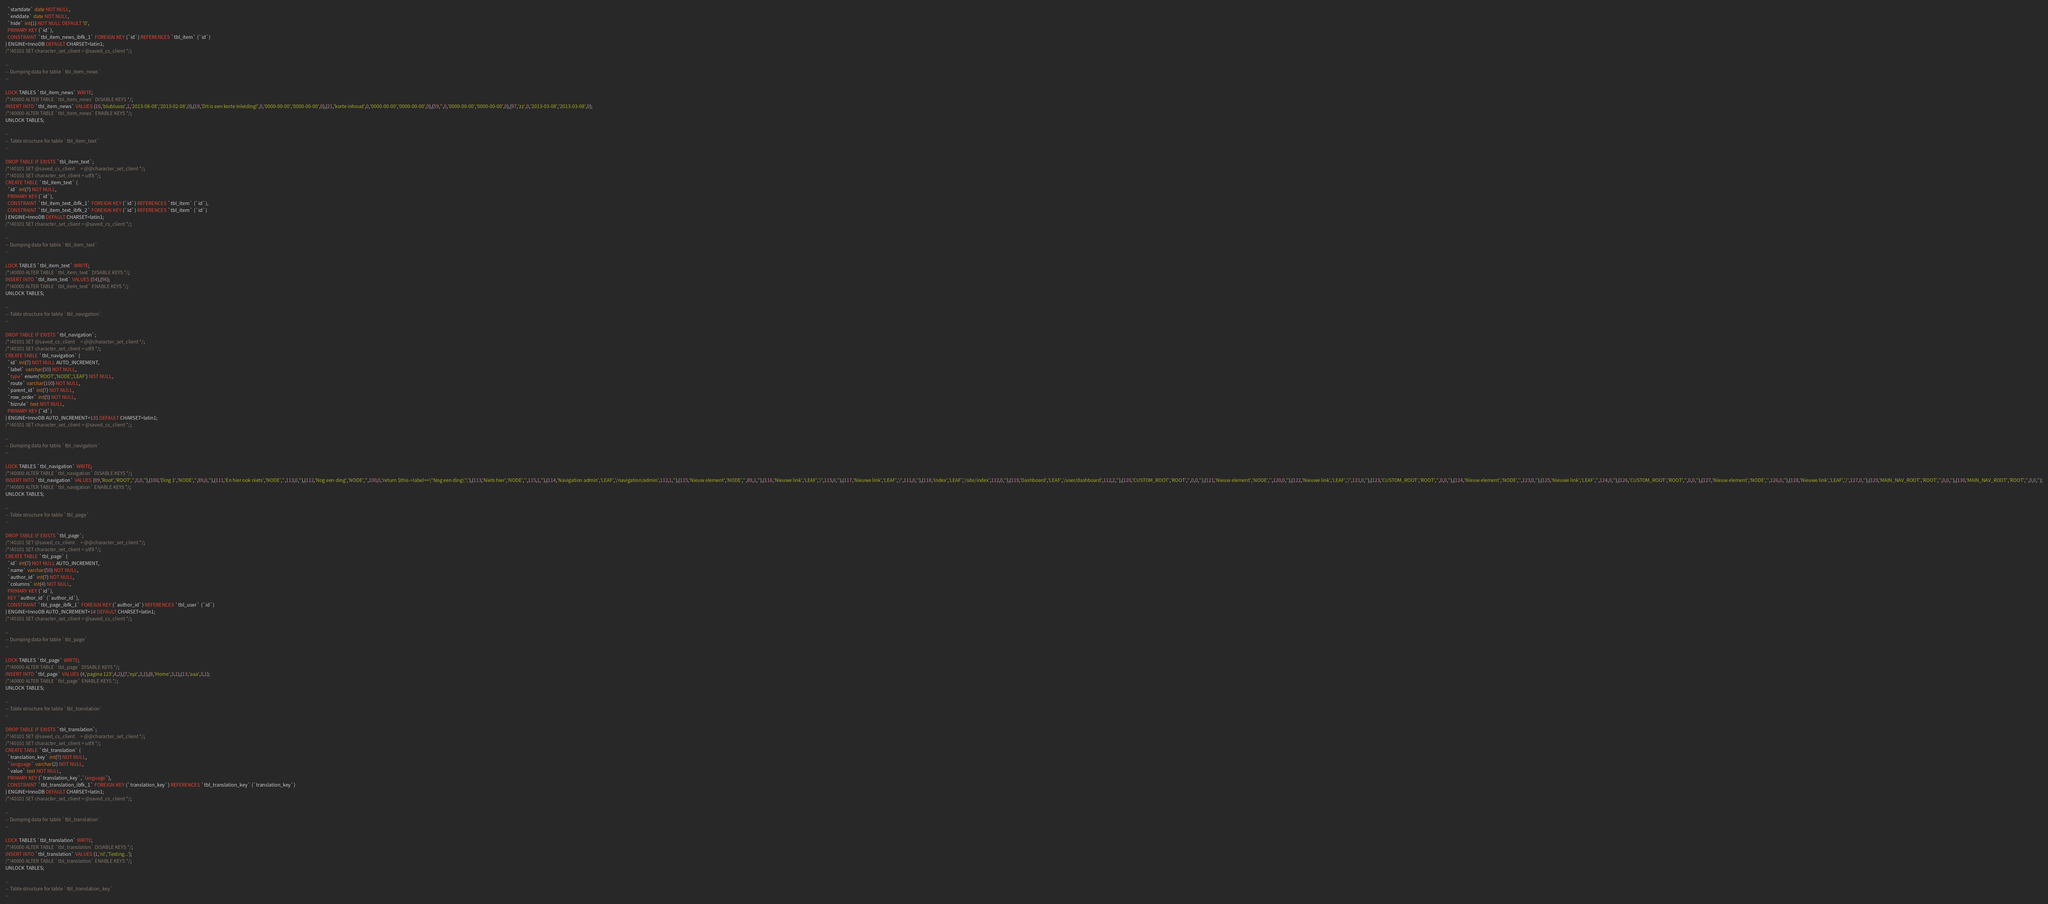Convert code to text. <code><loc_0><loc_0><loc_500><loc_500><_SQL_>  `startdate` date NOT NULL,
  `enddate` date NOT NULL,
  `hide` int(1) NOT NULL DEFAULT '0',
  PRIMARY KEY (`id`),
  CONSTRAINT `tbl_item_news_ibfk_1` FOREIGN KEY (`id`) REFERENCES `tbl_item` (`id`)
) ENGINE=InnoDB DEFAULT CHARSET=latin1;
/*!40101 SET character_set_client = @saved_cs_client */;

--
-- Dumping data for table `tbl_item_news`
--

LOCK TABLES `tbl_item_news` WRITE;
/*!40000 ALTER TABLE `tbl_item_news` DISABLE KEYS */;
INSERT INTO `tbl_item_news` VALUES (16,'blublusss',1,'2013-08-08','2013-02-08',0),(19,'Dit is een korte inleiding!',0,'0000-00-00','0000-00-00',0),(21,'korte inhoud',0,'0000-00-00','0000-00-00',0),(59,'',0,'0000-00-00','0000-00-00',0),(97,'zz',0,'2013-03-08','2013-03-08',0);
/*!40000 ALTER TABLE `tbl_item_news` ENABLE KEYS */;
UNLOCK TABLES;

--
-- Table structure for table `tbl_item_text`
--

DROP TABLE IF EXISTS `tbl_item_text`;
/*!40101 SET @saved_cs_client     = @@character_set_client */;
/*!40101 SET character_set_client = utf8 */;
CREATE TABLE `tbl_item_text` (
  `id` int(7) NOT NULL,
  PRIMARY KEY (`id`),
  CONSTRAINT `tbl_item_text_ibfk_1` FOREIGN KEY (`id`) REFERENCES `tbl_item` (`id`),
  CONSTRAINT `tbl_item_text_ibfk_2` FOREIGN KEY (`id`) REFERENCES `tbl_item` (`id`)
) ENGINE=InnoDB DEFAULT CHARSET=latin1;
/*!40101 SET character_set_client = @saved_cs_client */;

--
-- Dumping data for table `tbl_item_text`
--

LOCK TABLES `tbl_item_text` WRITE;
/*!40000 ALTER TABLE `tbl_item_text` DISABLE KEYS */;
INSERT INTO `tbl_item_text` VALUES (54),(96);
/*!40000 ALTER TABLE `tbl_item_text` ENABLE KEYS */;
UNLOCK TABLES;

--
-- Table structure for table `tbl_navigation`
--

DROP TABLE IF EXISTS `tbl_navigation`;
/*!40101 SET @saved_cs_client     = @@character_set_client */;
/*!40101 SET character_set_client = utf8 */;
CREATE TABLE `tbl_navigation` (
  `id` int(7) NOT NULL AUTO_INCREMENT,
  `label` varchar(50) NOT NULL,
  `type` enum('ROOT','NODE','LEAF') NOT NULL,
  `route` varchar(100) NOT NULL,
  `parent_id` int(7) NOT NULL,
  `row_order` int(5) NOT NULL,
  `bizrule` text NOT NULL,
  PRIMARY KEY (`id`)
) ENGINE=InnoDB AUTO_INCREMENT=131 DEFAULT CHARSET=latin1;
/*!40101 SET character_set_client = @saved_cs_client */;

--
-- Dumping data for table `tbl_navigation`
--

LOCK TABLES `tbl_navigation` WRITE;
/*!40000 ALTER TABLE `tbl_navigation` DISABLE KEYS */;
INSERT INTO `tbl_navigation` VALUES (89,'Root','ROOT','',0,0,''),(100,'Ding 1','NODE','',89,0,''),(111,'En hier ook niets','NODE','',113,0,''),(112,'Nog een ding','NODE','',100,0,'return $this->label==\"Nog een ding\";'),(113,'Niets hier','NODE','',115,1,''),(114,'Navigation admin','LEAF','/navigation/admin',112,1,''),(115,'Nieuw element','NODE','',89,1,''),(116,'Nieuwe link','LEAF','/',115,0,''),(117,'Nieuwe link','LEAF','/',111,0,''),(118,'Index','LEAF','/site/index',112,0,''),(119,'Dashboard','LEAF','/user/dashboard',112,2,''),(120,'CUSTOM_ROOT','ROOT','',0,0,''),(121,'Nieuw element','NODE','',120,0,''),(122,'Nieuwe link','LEAF','/',121,0,''),(123,'CUSTOM_ROOT','ROOT','',0,0,''),(124,'Nieuw element','NODE','',123,0,''),(125,'Nieuwe link','LEAF','',124,0,''),(126,'CUSTOM_ROOT','ROOT','',0,0,''),(127,'Nieuw element','NODE','',126,0,''),(128,'Nieuwe link','LEAF','/',127,0,''),(129,'MAIN_NAV_ROOT','ROOT','',0,0,''),(130,'MAIN_NAV_ROOT','ROOT','',0,0,'');
/*!40000 ALTER TABLE `tbl_navigation` ENABLE KEYS */;
UNLOCK TABLES;

--
-- Table structure for table `tbl_page`
--

DROP TABLE IF EXISTS `tbl_page`;
/*!40101 SET @saved_cs_client     = @@character_set_client */;
/*!40101 SET character_set_client = utf8 */;
CREATE TABLE `tbl_page` (
  `id` int(7) NOT NULL AUTO_INCREMENT,
  `name` varchar(50) NOT NULL,
  `author_id` int(7) NOT NULL,
  `columns` int(4) NOT NULL,
  PRIMARY KEY (`id`),
  KEY `author_id` (`author_id`),
  CONSTRAINT `tbl_page_ibfk_1` FOREIGN KEY (`author_id`) REFERENCES `tbl_user` (`id`)
) ENGINE=InnoDB AUTO_INCREMENT=14 DEFAULT CHARSET=latin1;
/*!40101 SET character_set_client = @saved_cs_client */;

--
-- Dumping data for table `tbl_page`
--

LOCK TABLES `tbl_page` WRITE;
/*!40000 ALTER TABLE `tbl_page` DISABLE KEYS */;
INSERT INTO `tbl_page` VALUES (4,'pagina 123',4,2),(7,'xyz',3,1),(8,'Home',3,1),(13,'aaa',3,1);
/*!40000 ALTER TABLE `tbl_page` ENABLE KEYS */;
UNLOCK TABLES;

--
-- Table structure for table `tbl_translation`
--

DROP TABLE IF EXISTS `tbl_translation`;
/*!40101 SET @saved_cs_client     = @@character_set_client */;
/*!40101 SET character_set_client = utf8 */;
CREATE TABLE `tbl_translation` (
  `translation_key` int(7) NOT NULL,
  `language` varchar(2) NOT NULL,
  `value` text NOT NULL,
  PRIMARY KEY (`translation_key`,`language`),
  CONSTRAINT `tbl_translation_ibfk_1` FOREIGN KEY (`translation_key`) REFERENCES `tbl_translation_key` (`translation_key`)
) ENGINE=InnoDB DEFAULT CHARSET=latin1;
/*!40101 SET character_set_client = @saved_cs_client */;

--
-- Dumping data for table `tbl_translation`
--

LOCK TABLES `tbl_translation` WRITE;
/*!40000 ALTER TABLE `tbl_translation` DISABLE KEYS */;
INSERT INTO `tbl_translation` VALUES (1,'nl','Testing...');
/*!40000 ALTER TABLE `tbl_translation` ENABLE KEYS */;
UNLOCK TABLES;

--
-- Table structure for table `tbl_translation_key`
--
</code> 